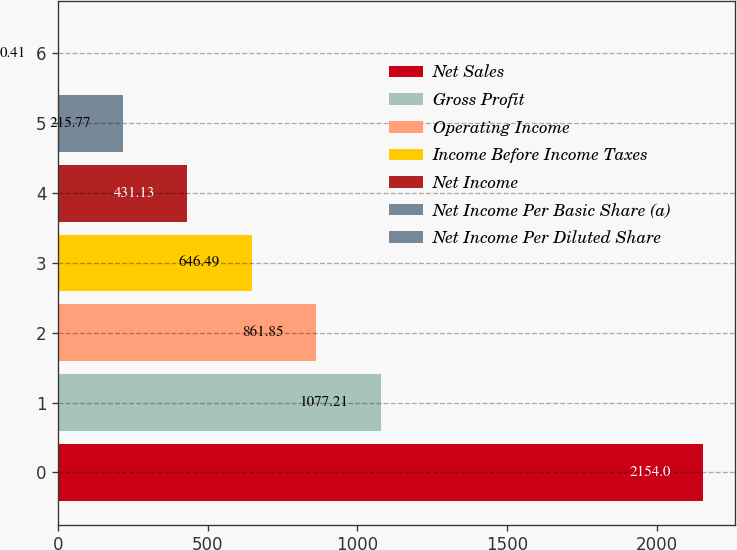Convert chart. <chart><loc_0><loc_0><loc_500><loc_500><bar_chart><fcel>Net Sales<fcel>Gross Profit<fcel>Operating Income<fcel>Income Before Income Taxes<fcel>Net Income<fcel>Net Income Per Basic Share (a)<fcel>Net Income Per Diluted Share<nl><fcel>2154<fcel>1077.21<fcel>861.85<fcel>646.49<fcel>431.13<fcel>215.77<fcel>0.41<nl></chart> 